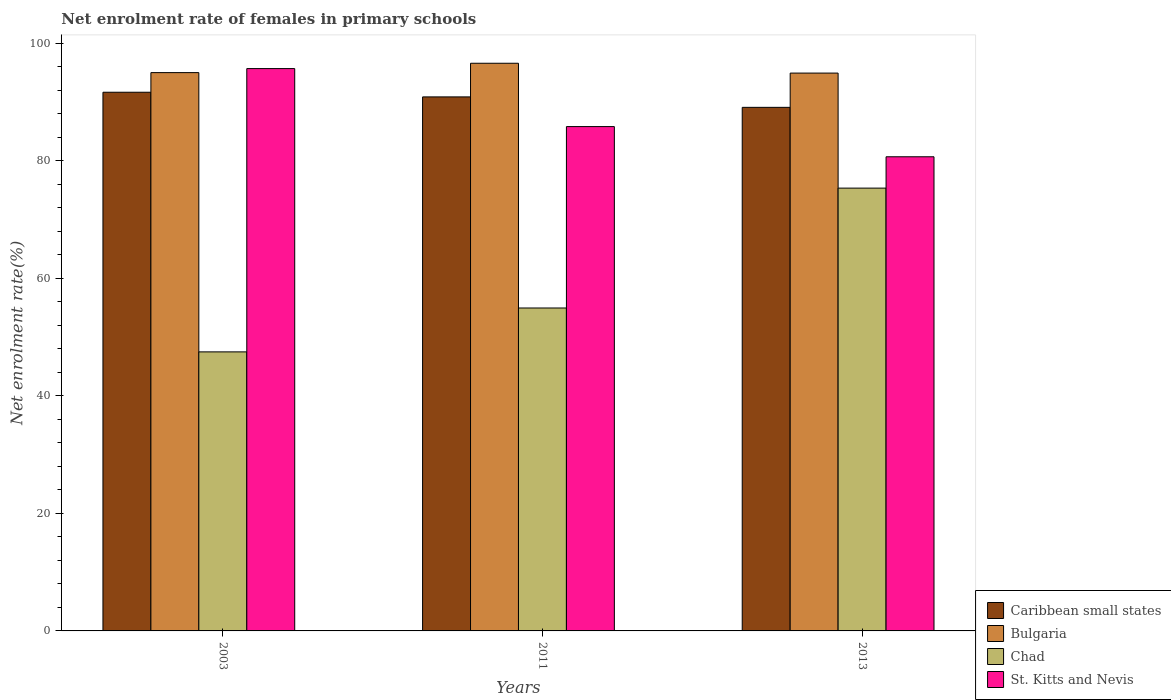Are the number of bars on each tick of the X-axis equal?
Provide a short and direct response. Yes. What is the net enrolment rate of females in primary schools in St. Kitts and Nevis in 2013?
Your response must be concise. 80.7. Across all years, what is the maximum net enrolment rate of females in primary schools in Bulgaria?
Provide a short and direct response. 96.62. Across all years, what is the minimum net enrolment rate of females in primary schools in Bulgaria?
Your answer should be compact. 94.94. In which year was the net enrolment rate of females in primary schools in Caribbean small states maximum?
Provide a succinct answer. 2003. What is the total net enrolment rate of females in primary schools in St. Kitts and Nevis in the graph?
Your answer should be compact. 262.25. What is the difference between the net enrolment rate of females in primary schools in Caribbean small states in 2011 and that in 2013?
Offer a very short reply. 1.78. What is the difference between the net enrolment rate of females in primary schools in Bulgaria in 2011 and the net enrolment rate of females in primary schools in Chad in 2013?
Give a very brief answer. 21.25. What is the average net enrolment rate of females in primary schools in Caribbean small states per year?
Your answer should be very brief. 90.56. In the year 2013, what is the difference between the net enrolment rate of females in primary schools in Bulgaria and net enrolment rate of females in primary schools in Chad?
Keep it short and to the point. 19.58. What is the ratio of the net enrolment rate of females in primary schools in Chad in 2003 to that in 2011?
Your response must be concise. 0.86. Is the net enrolment rate of females in primary schools in Caribbean small states in 2003 less than that in 2013?
Offer a terse response. No. What is the difference between the highest and the second highest net enrolment rate of females in primary schools in St. Kitts and Nevis?
Give a very brief answer. 9.87. What is the difference between the highest and the lowest net enrolment rate of females in primary schools in St. Kitts and Nevis?
Your answer should be very brief. 15.01. Is it the case that in every year, the sum of the net enrolment rate of females in primary schools in Caribbean small states and net enrolment rate of females in primary schools in Bulgaria is greater than the sum of net enrolment rate of females in primary schools in St. Kitts and Nevis and net enrolment rate of females in primary schools in Chad?
Give a very brief answer. Yes. What does the 1st bar from the left in 2011 represents?
Offer a very short reply. Caribbean small states. What does the 2nd bar from the right in 2013 represents?
Keep it short and to the point. Chad. Are all the bars in the graph horizontal?
Provide a succinct answer. No. How many years are there in the graph?
Give a very brief answer. 3. What is the difference between two consecutive major ticks on the Y-axis?
Provide a short and direct response. 20. Does the graph contain any zero values?
Offer a terse response. No. Where does the legend appear in the graph?
Make the answer very short. Bottom right. How many legend labels are there?
Keep it short and to the point. 4. What is the title of the graph?
Give a very brief answer. Net enrolment rate of females in primary schools. Does "Armenia" appear as one of the legend labels in the graph?
Provide a short and direct response. No. What is the label or title of the X-axis?
Provide a succinct answer. Years. What is the label or title of the Y-axis?
Offer a terse response. Net enrolment rate(%). What is the Net enrolment rate(%) in Caribbean small states in 2003?
Offer a terse response. 91.69. What is the Net enrolment rate(%) of Bulgaria in 2003?
Keep it short and to the point. 95.02. What is the Net enrolment rate(%) of Chad in 2003?
Your answer should be very brief. 47.49. What is the Net enrolment rate(%) of St. Kitts and Nevis in 2003?
Your answer should be compact. 95.71. What is the Net enrolment rate(%) in Caribbean small states in 2011?
Your response must be concise. 90.89. What is the Net enrolment rate(%) of Bulgaria in 2011?
Give a very brief answer. 96.62. What is the Net enrolment rate(%) of Chad in 2011?
Offer a terse response. 54.96. What is the Net enrolment rate(%) of St. Kitts and Nevis in 2011?
Your response must be concise. 85.84. What is the Net enrolment rate(%) in Caribbean small states in 2013?
Make the answer very short. 89.11. What is the Net enrolment rate(%) in Bulgaria in 2013?
Make the answer very short. 94.94. What is the Net enrolment rate(%) in Chad in 2013?
Your answer should be compact. 75.37. What is the Net enrolment rate(%) in St. Kitts and Nevis in 2013?
Your answer should be compact. 80.7. Across all years, what is the maximum Net enrolment rate(%) of Caribbean small states?
Your answer should be very brief. 91.69. Across all years, what is the maximum Net enrolment rate(%) of Bulgaria?
Your response must be concise. 96.62. Across all years, what is the maximum Net enrolment rate(%) in Chad?
Provide a succinct answer. 75.37. Across all years, what is the maximum Net enrolment rate(%) of St. Kitts and Nevis?
Give a very brief answer. 95.71. Across all years, what is the minimum Net enrolment rate(%) in Caribbean small states?
Make the answer very short. 89.11. Across all years, what is the minimum Net enrolment rate(%) of Bulgaria?
Ensure brevity in your answer.  94.94. Across all years, what is the minimum Net enrolment rate(%) of Chad?
Ensure brevity in your answer.  47.49. Across all years, what is the minimum Net enrolment rate(%) of St. Kitts and Nevis?
Give a very brief answer. 80.7. What is the total Net enrolment rate(%) of Caribbean small states in the graph?
Offer a very short reply. 271.69. What is the total Net enrolment rate(%) of Bulgaria in the graph?
Ensure brevity in your answer.  286.59. What is the total Net enrolment rate(%) in Chad in the graph?
Offer a very short reply. 177.82. What is the total Net enrolment rate(%) in St. Kitts and Nevis in the graph?
Your answer should be compact. 262.25. What is the difference between the Net enrolment rate(%) in Caribbean small states in 2003 and that in 2011?
Offer a terse response. 0.79. What is the difference between the Net enrolment rate(%) in Bulgaria in 2003 and that in 2011?
Make the answer very short. -1.59. What is the difference between the Net enrolment rate(%) of Chad in 2003 and that in 2011?
Provide a short and direct response. -7.47. What is the difference between the Net enrolment rate(%) in St. Kitts and Nevis in 2003 and that in 2011?
Keep it short and to the point. 9.87. What is the difference between the Net enrolment rate(%) in Caribbean small states in 2003 and that in 2013?
Your answer should be compact. 2.57. What is the difference between the Net enrolment rate(%) of Bulgaria in 2003 and that in 2013?
Your answer should be very brief. 0.08. What is the difference between the Net enrolment rate(%) in Chad in 2003 and that in 2013?
Ensure brevity in your answer.  -27.87. What is the difference between the Net enrolment rate(%) of St. Kitts and Nevis in 2003 and that in 2013?
Offer a very short reply. 15.01. What is the difference between the Net enrolment rate(%) of Caribbean small states in 2011 and that in 2013?
Your answer should be very brief. 1.78. What is the difference between the Net enrolment rate(%) in Bulgaria in 2011 and that in 2013?
Offer a very short reply. 1.67. What is the difference between the Net enrolment rate(%) of Chad in 2011 and that in 2013?
Provide a short and direct response. -20.4. What is the difference between the Net enrolment rate(%) of St. Kitts and Nevis in 2011 and that in 2013?
Your answer should be compact. 5.14. What is the difference between the Net enrolment rate(%) of Caribbean small states in 2003 and the Net enrolment rate(%) of Bulgaria in 2011?
Ensure brevity in your answer.  -4.93. What is the difference between the Net enrolment rate(%) in Caribbean small states in 2003 and the Net enrolment rate(%) in Chad in 2011?
Offer a terse response. 36.72. What is the difference between the Net enrolment rate(%) in Caribbean small states in 2003 and the Net enrolment rate(%) in St. Kitts and Nevis in 2011?
Your answer should be very brief. 5.84. What is the difference between the Net enrolment rate(%) in Bulgaria in 2003 and the Net enrolment rate(%) in Chad in 2011?
Give a very brief answer. 40.06. What is the difference between the Net enrolment rate(%) in Bulgaria in 2003 and the Net enrolment rate(%) in St. Kitts and Nevis in 2011?
Offer a terse response. 9.18. What is the difference between the Net enrolment rate(%) of Chad in 2003 and the Net enrolment rate(%) of St. Kitts and Nevis in 2011?
Your response must be concise. -38.35. What is the difference between the Net enrolment rate(%) of Caribbean small states in 2003 and the Net enrolment rate(%) of Bulgaria in 2013?
Make the answer very short. -3.26. What is the difference between the Net enrolment rate(%) of Caribbean small states in 2003 and the Net enrolment rate(%) of Chad in 2013?
Keep it short and to the point. 16.32. What is the difference between the Net enrolment rate(%) of Caribbean small states in 2003 and the Net enrolment rate(%) of St. Kitts and Nevis in 2013?
Your answer should be very brief. 10.98. What is the difference between the Net enrolment rate(%) in Bulgaria in 2003 and the Net enrolment rate(%) in Chad in 2013?
Give a very brief answer. 19.66. What is the difference between the Net enrolment rate(%) of Bulgaria in 2003 and the Net enrolment rate(%) of St. Kitts and Nevis in 2013?
Your answer should be very brief. 14.32. What is the difference between the Net enrolment rate(%) of Chad in 2003 and the Net enrolment rate(%) of St. Kitts and Nevis in 2013?
Provide a succinct answer. -33.21. What is the difference between the Net enrolment rate(%) of Caribbean small states in 2011 and the Net enrolment rate(%) of Bulgaria in 2013?
Give a very brief answer. -4.05. What is the difference between the Net enrolment rate(%) in Caribbean small states in 2011 and the Net enrolment rate(%) in Chad in 2013?
Your response must be concise. 15.53. What is the difference between the Net enrolment rate(%) in Caribbean small states in 2011 and the Net enrolment rate(%) in St. Kitts and Nevis in 2013?
Make the answer very short. 10.19. What is the difference between the Net enrolment rate(%) in Bulgaria in 2011 and the Net enrolment rate(%) in Chad in 2013?
Ensure brevity in your answer.  21.25. What is the difference between the Net enrolment rate(%) of Bulgaria in 2011 and the Net enrolment rate(%) of St. Kitts and Nevis in 2013?
Your answer should be compact. 15.92. What is the difference between the Net enrolment rate(%) in Chad in 2011 and the Net enrolment rate(%) in St. Kitts and Nevis in 2013?
Make the answer very short. -25.74. What is the average Net enrolment rate(%) of Caribbean small states per year?
Your answer should be compact. 90.56. What is the average Net enrolment rate(%) in Bulgaria per year?
Keep it short and to the point. 95.53. What is the average Net enrolment rate(%) of Chad per year?
Ensure brevity in your answer.  59.27. What is the average Net enrolment rate(%) of St. Kitts and Nevis per year?
Offer a very short reply. 87.42. In the year 2003, what is the difference between the Net enrolment rate(%) in Caribbean small states and Net enrolment rate(%) in Bulgaria?
Offer a very short reply. -3.34. In the year 2003, what is the difference between the Net enrolment rate(%) of Caribbean small states and Net enrolment rate(%) of Chad?
Your answer should be very brief. 44.19. In the year 2003, what is the difference between the Net enrolment rate(%) of Caribbean small states and Net enrolment rate(%) of St. Kitts and Nevis?
Offer a very short reply. -4.03. In the year 2003, what is the difference between the Net enrolment rate(%) of Bulgaria and Net enrolment rate(%) of Chad?
Give a very brief answer. 47.53. In the year 2003, what is the difference between the Net enrolment rate(%) of Bulgaria and Net enrolment rate(%) of St. Kitts and Nevis?
Keep it short and to the point. -0.69. In the year 2003, what is the difference between the Net enrolment rate(%) in Chad and Net enrolment rate(%) in St. Kitts and Nevis?
Offer a very short reply. -48.22. In the year 2011, what is the difference between the Net enrolment rate(%) in Caribbean small states and Net enrolment rate(%) in Bulgaria?
Provide a succinct answer. -5.73. In the year 2011, what is the difference between the Net enrolment rate(%) of Caribbean small states and Net enrolment rate(%) of Chad?
Offer a very short reply. 35.93. In the year 2011, what is the difference between the Net enrolment rate(%) in Caribbean small states and Net enrolment rate(%) in St. Kitts and Nevis?
Your response must be concise. 5.05. In the year 2011, what is the difference between the Net enrolment rate(%) of Bulgaria and Net enrolment rate(%) of Chad?
Your response must be concise. 41.65. In the year 2011, what is the difference between the Net enrolment rate(%) in Bulgaria and Net enrolment rate(%) in St. Kitts and Nevis?
Provide a succinct answer. 10.78. In the year 2011, what is the difference between the Net enrolment rate(%) of Chad and Net enrolment rate(%) of St. Kitts and Nevis?
Keep it short and to the point. -30.88. In the year 2013, what is the difference between the Net enrolment rate(%) in Caribbean small states and Net enrolment rate(%) in Bulgaria?
Keep it short and to the point. -5.83. In the year 2013, what is the difference between the Net enrolment rate(%) in Caribbean small states and Net enrolment rate(%) in Chad?
Give a very brief answer. 13.75. In the year 2013, what is the difference between the Net enrolment rate(%) of Caribbean small states and Net enrolment rate(%) of St. Kitts and Nevis?
Your answer should be compact. 8.41. In the year 2013, what is the difference between the Net enrolment rate(%) in Bulgaria and Net enrolment rate(%) in Chad?
Ensure brevity in your answer.  19.58. In the year 2013, what is the difference between the Net enrolment rate(%) of Bulgaria and Net enrolment rate(%) of St. Kitts and Nevis?
Give a very brief answer. 14.24. In the year 2013, what is the difference between the Net enrolment rate(%) in Chad and Net enrolment rate(%) in St. Kitts and Nevis?
Provide a short and direct response. -5.33. What is the ratio of the Net enrolment rate(%) in Caribbean small states in 2003 to that in 2011?
Offer a terse response. 1.01. What is the ratio of the Net enrolment rate(%) of Bulgaria in 2003 to that in 2011?
Your answer should be very brief. 0.98. What is the ratio of the Net enrolment rate(%) of Chad in 2003 to that in 2011?
Make the answer very short. 0.86. What is the ratio of the Net enrolment rate(%) of St. Kitts and Nevis in 2003 to that in 2011?
Provide a short and direct response. 1.11. What is the ratio of the Net enrolment rate(%) of Caribbean small states in 2003 to that in 2013?
Offer a terse response. 1.03. What is the ratio of the Net enrolment rate(%) of Chad in 2003 to that in 2013?
Keep it short and to the point. 0.63. What is the ratio of the Net enrolment rate(%) in St. Kitts and Nevis in 2003 to that in 2013?
Offer a very short reply. 1.19. What is the ratio of the Net enrolment rate(%) in Caribbean small states in 2011 to that in 2013?
Provide a succinct answer. 1.02. What is the ratio of the Net enrolment rate(%) in Bulgaria in 2011 to that in 2013?
Keep it short and to the point. 1.02. What is the ratio of the Net enrolment rate(%) of Chad in 2011 to that in 2013?
Offer a terse response. 0.73. What is the ratio of the Net enrolment rate(%) in St. Kitts and Nevis in 2011 to that in 2013?
Provide a short and direct response. 1.06. What is the difference between the highest and the second highest Net enrolment rate(%) of Caribbean small states?
Keep it short and to the point. 0.79. What is the difference between the highest and the second highest Net enrolment rate(%) in Bulgaria?
Offer a terse response. 1.59. What is the difference between the highest and the second highest Net enrolment rate(%) of Chad?
Offer a very short reply. 20.4. What is the difference between the highest and the second highest Net enrolment rate(%) in St. Kitts and Nevis?
Ensure brevity in your answer.  9.87. What is the difference between the highest and the lowest Net enrolment rate(%) in Caribbean small states?
Make the answer very short. 2.57. What is the difference between the highest and the lowest Net enrolment rate(%) of Bulgaria?
Ensure brevity in your answer.  1.67. What is the difference between the highest and the lowest Net enrolment rate(%) of Chad?
Your response must be concise. 27.87. What is the difference between the highest and the lowest Net enrolment rate(%) in St. Kitts and Nevis?
Your answer should be very brief. 15.01. 